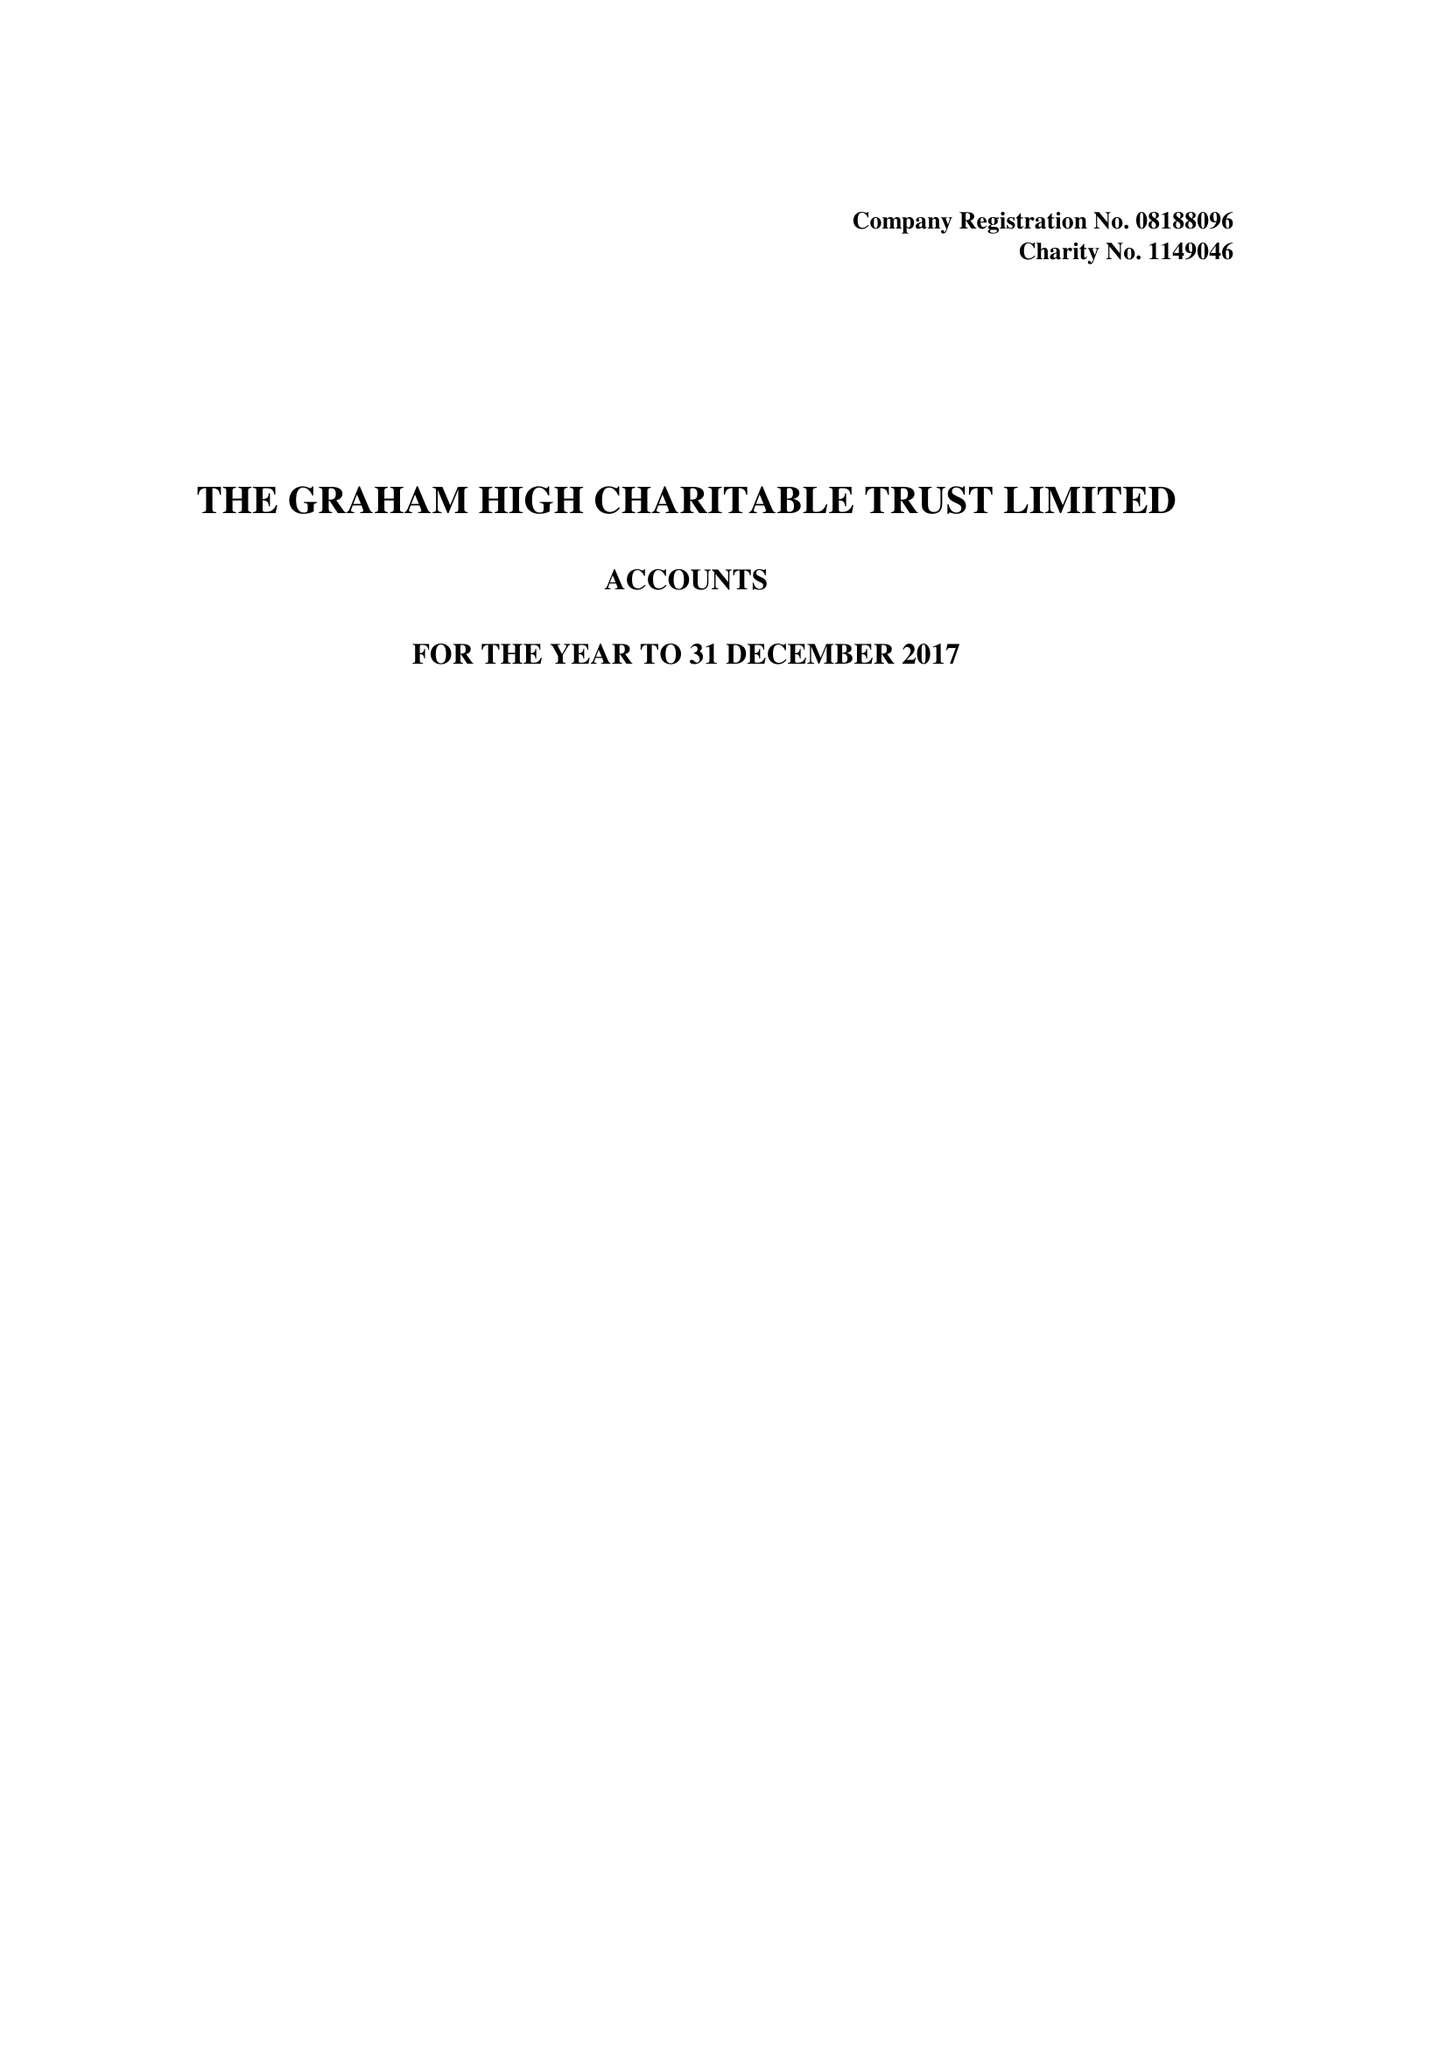What is the value for the address__street_line?
Answer the question using a single word or phrase. None 